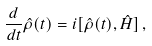Convert formula to latex. <formula><loc_0><loc_0><loc_500><loc_500>\frac { d } { d t } \hat { \rho } ( t ) = i [ \hat { \rho } ( t ) , \hat { H } ] \, ,</formula> 